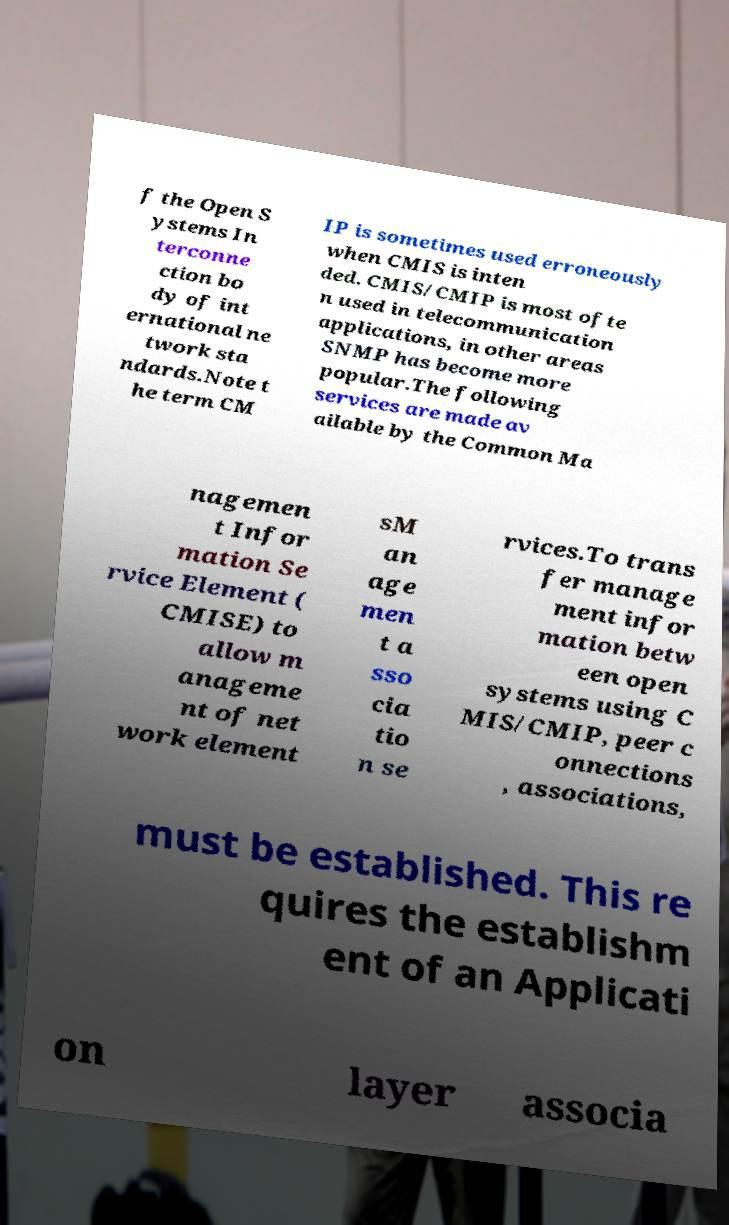Can you accurately transcribe the text from the provided image for me? f the Open S ystems In terconne ction bo dy of int ernational ne twork sta ndards.Note t he term CM IP is sometimes used erroneously when CMIS is inten ded. CMIS/CMIP is most ofte n used in telecommunication applications, in other areas SNMP has become more popular.The following services are made av ailable by the Common Ma nagemen t Infor mation Se rvice Element ( CMISE) to allow m anageme nt of net work element sM an age men t a sso cia tio n se rvices.To trans fer manage ment infor mation betw een open systems using C MIS/CMIP, peer c onnections , associations, must be established. This re quires the establishm ent of an Applicati on layer associa 